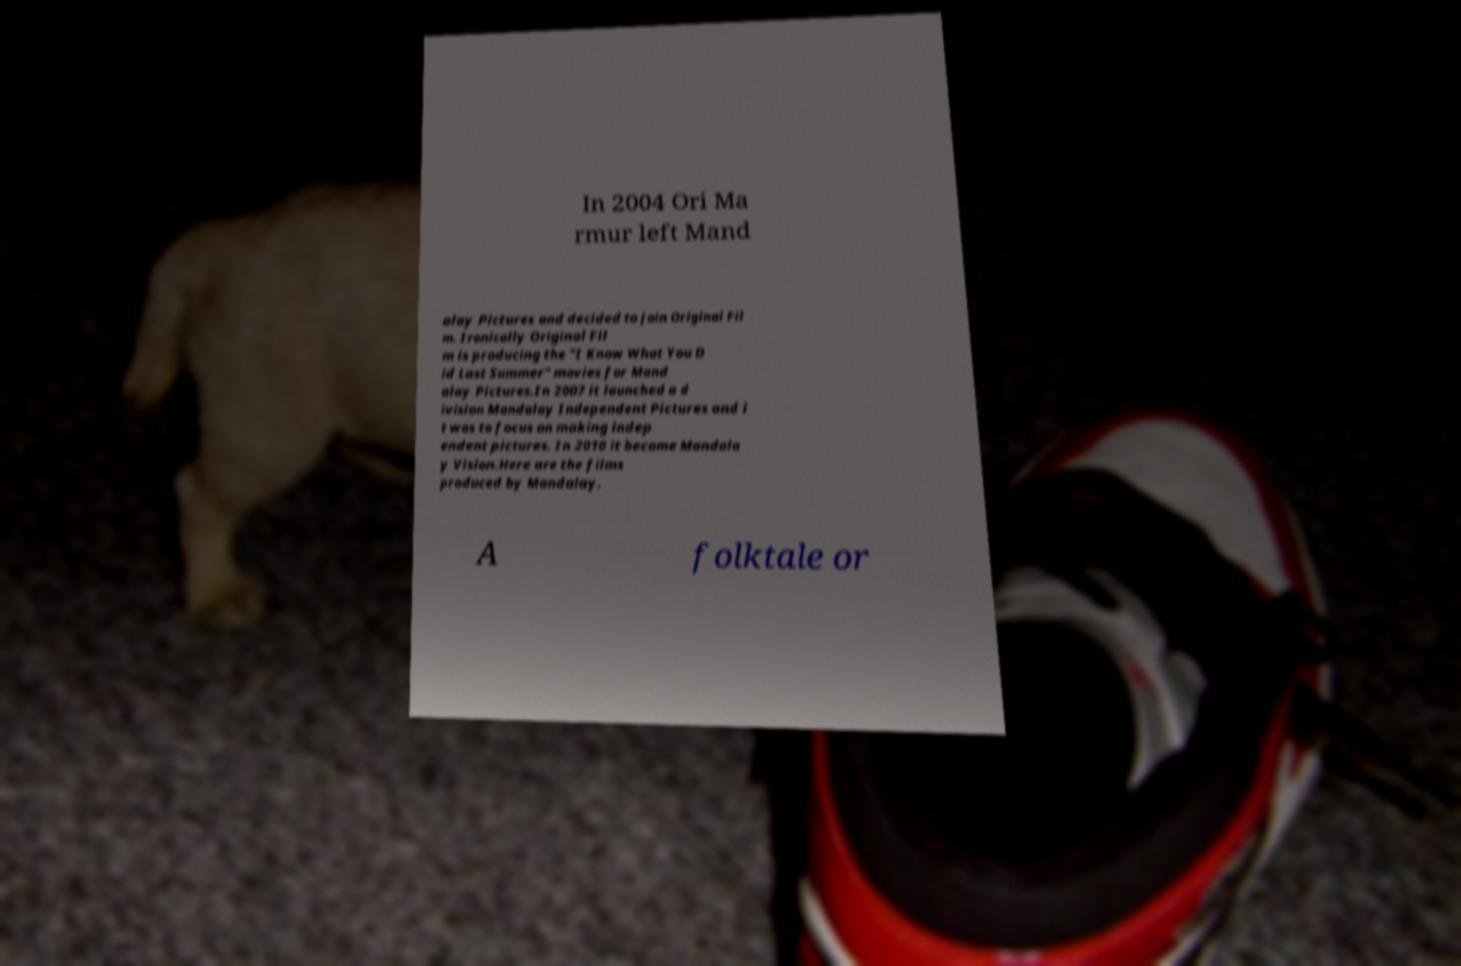Can you accurately transcribe the text from the provided image for me? In 2004 Ori Ma rmur left Mand alay Pictures and decided to join Original Fil m. Ironically Original Fil m is producing the "I Know What You D id Last Summer" movies for Mand alay Pictures.In 2007 it launched a d ivision Mandalay Independent Pictures and i t was to focus on making indep endent pictures. In 2010 it became Mandala y Vision.Here are the films produced by Mandalay. A folktale or 